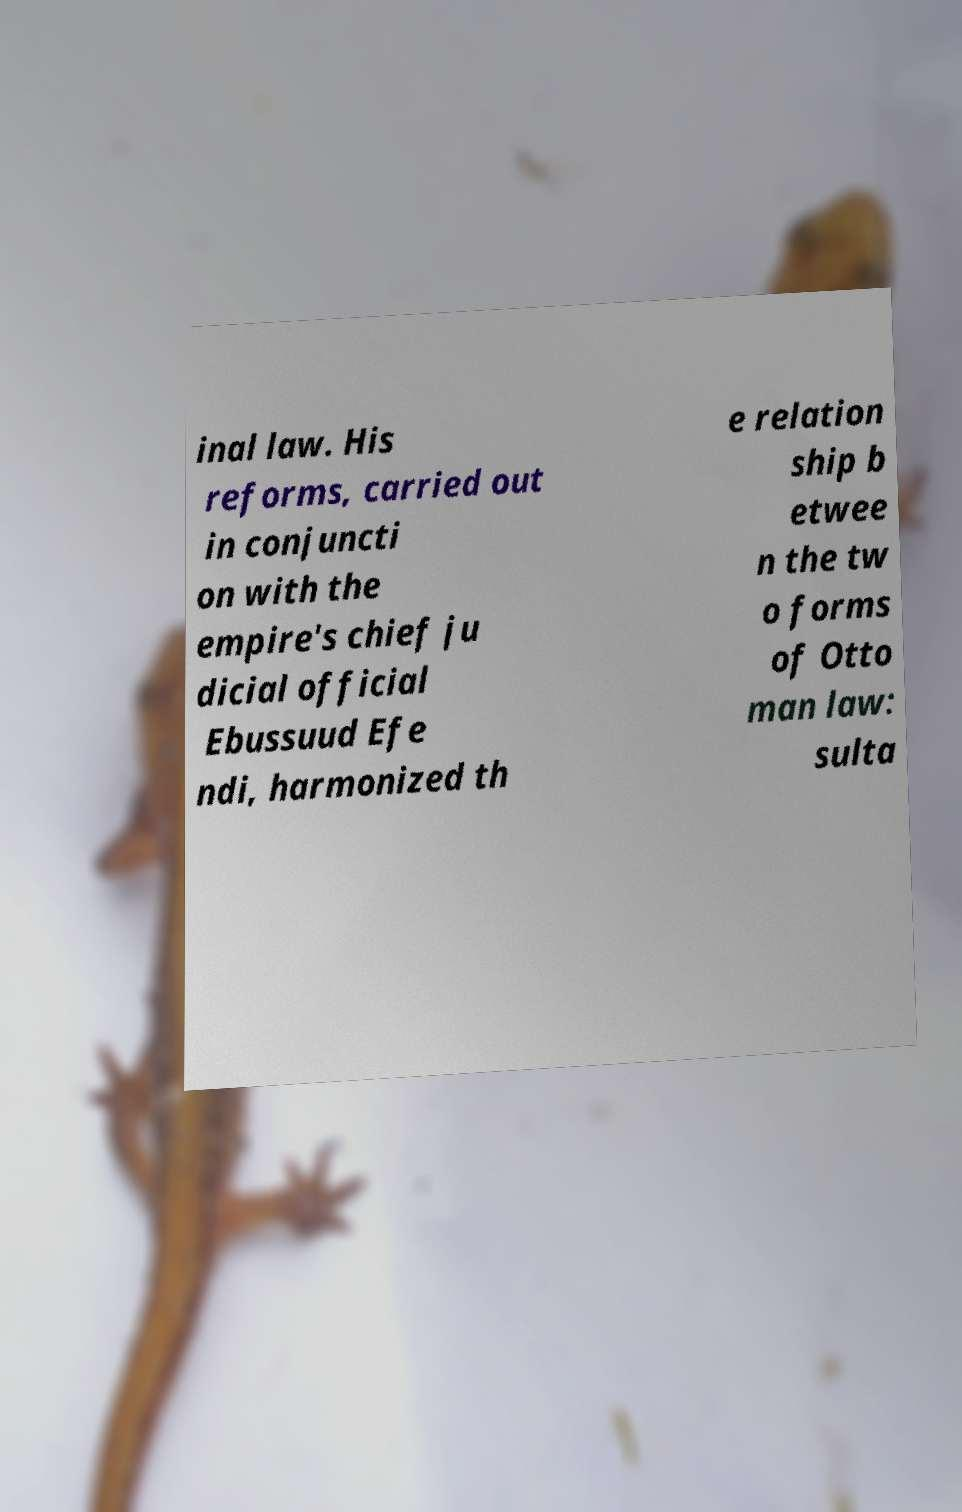Please identify and transcribe the text found in this image. inal law. His reforms, carried out in conjuncti on with the empire's chief ju dicial official Ebussuud Efe ndi, harmonized th e relation ship b etwee n the tw o forms of Otto man law: sulta 